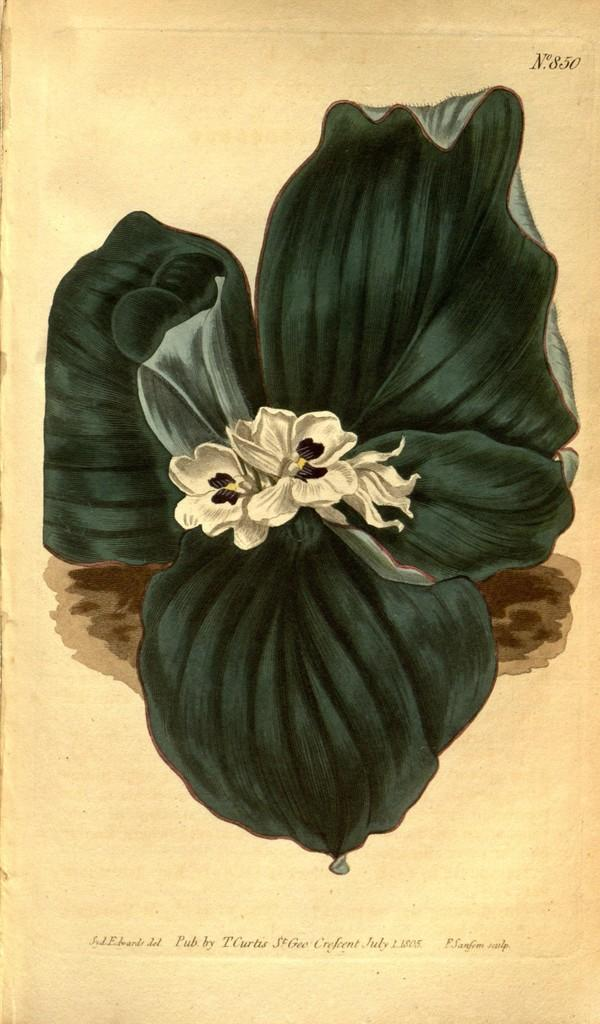What is present on the paper in the image? The paper has a depiction of a plant and flowers on it. Are there any words or symbols on the paper? Yes, there is text on the paper. What type of fruit is hanging from the cobweb in the image? There is no fruit or cobweb present in the image; it only features a paper with a plant and flowers depicted on it. 